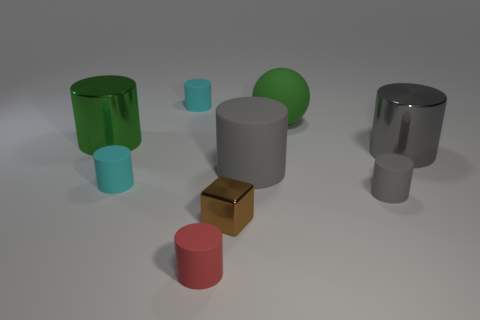What number of things are large balls or large cylinders that are to the left of the brown cube?
Provide a succinct answer. 2. Is the number of big cylinders in front of the gray metal cylinder less than the number of small red cylinders behind the small brown shiny cube?
Make the answer very short. No. How many other things are there of the same material as the tiny cube?
Keep it short and to the point. 2. There is a large cylinder to the left of the brown thing; does it have the same color as the big rubber cylinder?
Make the answer very short. No. There is a big shiny thing left of the brown thing; are there any small brown metal cubes behind it?
Provide a short and direct response. No. What material is the tiny object that is in front of the large ball and to the left of the small red thing?
Give a very brief answer. Rubber. What shape is the tiny red object that is made of the same material as the large sphere?
Make the answer very short. Cylinder. Are there any other things that are the same shape as the brown metal thing?
Your answer should be compact. No. Do the small cylinder that is in front of the brown shiny block and the small brown thing have the same material?
Make the answer very short. No. What is the big gray cylinder that is in front of the large gray shiny cylinder made of?
Your answer should be very brief. Rubber. 